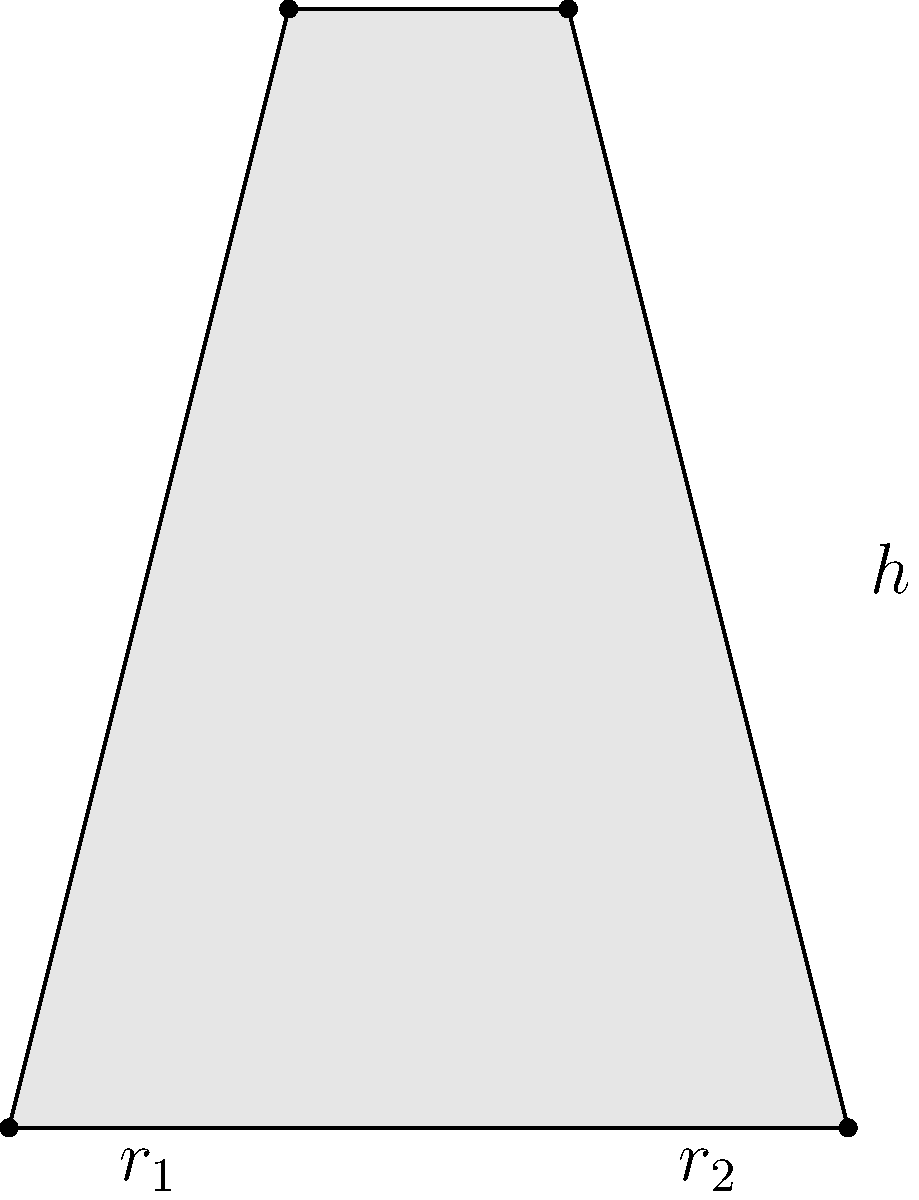In your latest avant-garde film, you want to feature a unique wine glass shaped like a truncated cone. The glass has a height of 15 cm, a bottom radius of 4 cm, and a top radius of 2 cm. What is the volume of this artistic wine glass in cubic centimeters? Round your answer to the nearest whole number. To find the volume of a truncated cone, we can use the formula:

$$V = \frac{1}{3}\pi h(r_1^2 + r_2^2 + r_1r_2)$$

Where:
$V$ = volume
$h$ = height
$r_1$ = radius of the base
$r_2$ = radius of the top

Given:
$h = 15$ cm
$r_1 = 4$ cm
$r_2 = 2$ cm

Let's substitute these values into the formula:

$$V = \frac{1}{3}\pi \cdot 15(4^2 + 2^2 + 4 \cdot 2)$$

$$V = 5\pi(16 + 4 + 8)$$

$$V = 5\pi(28)$$

$$V = 140\pi$$

$$V \approx 439.82 \text{ cm}^3$$

Rounding to the nearest whole number:

$$V \approx 440 \text{ cm}^3$$

This unique, avant-garde wine glass design holds approximately 440 cubic centimeters of liquid, perfect for serving an experimental wine in your artistic film scene.
Answer: 440 cm³ 